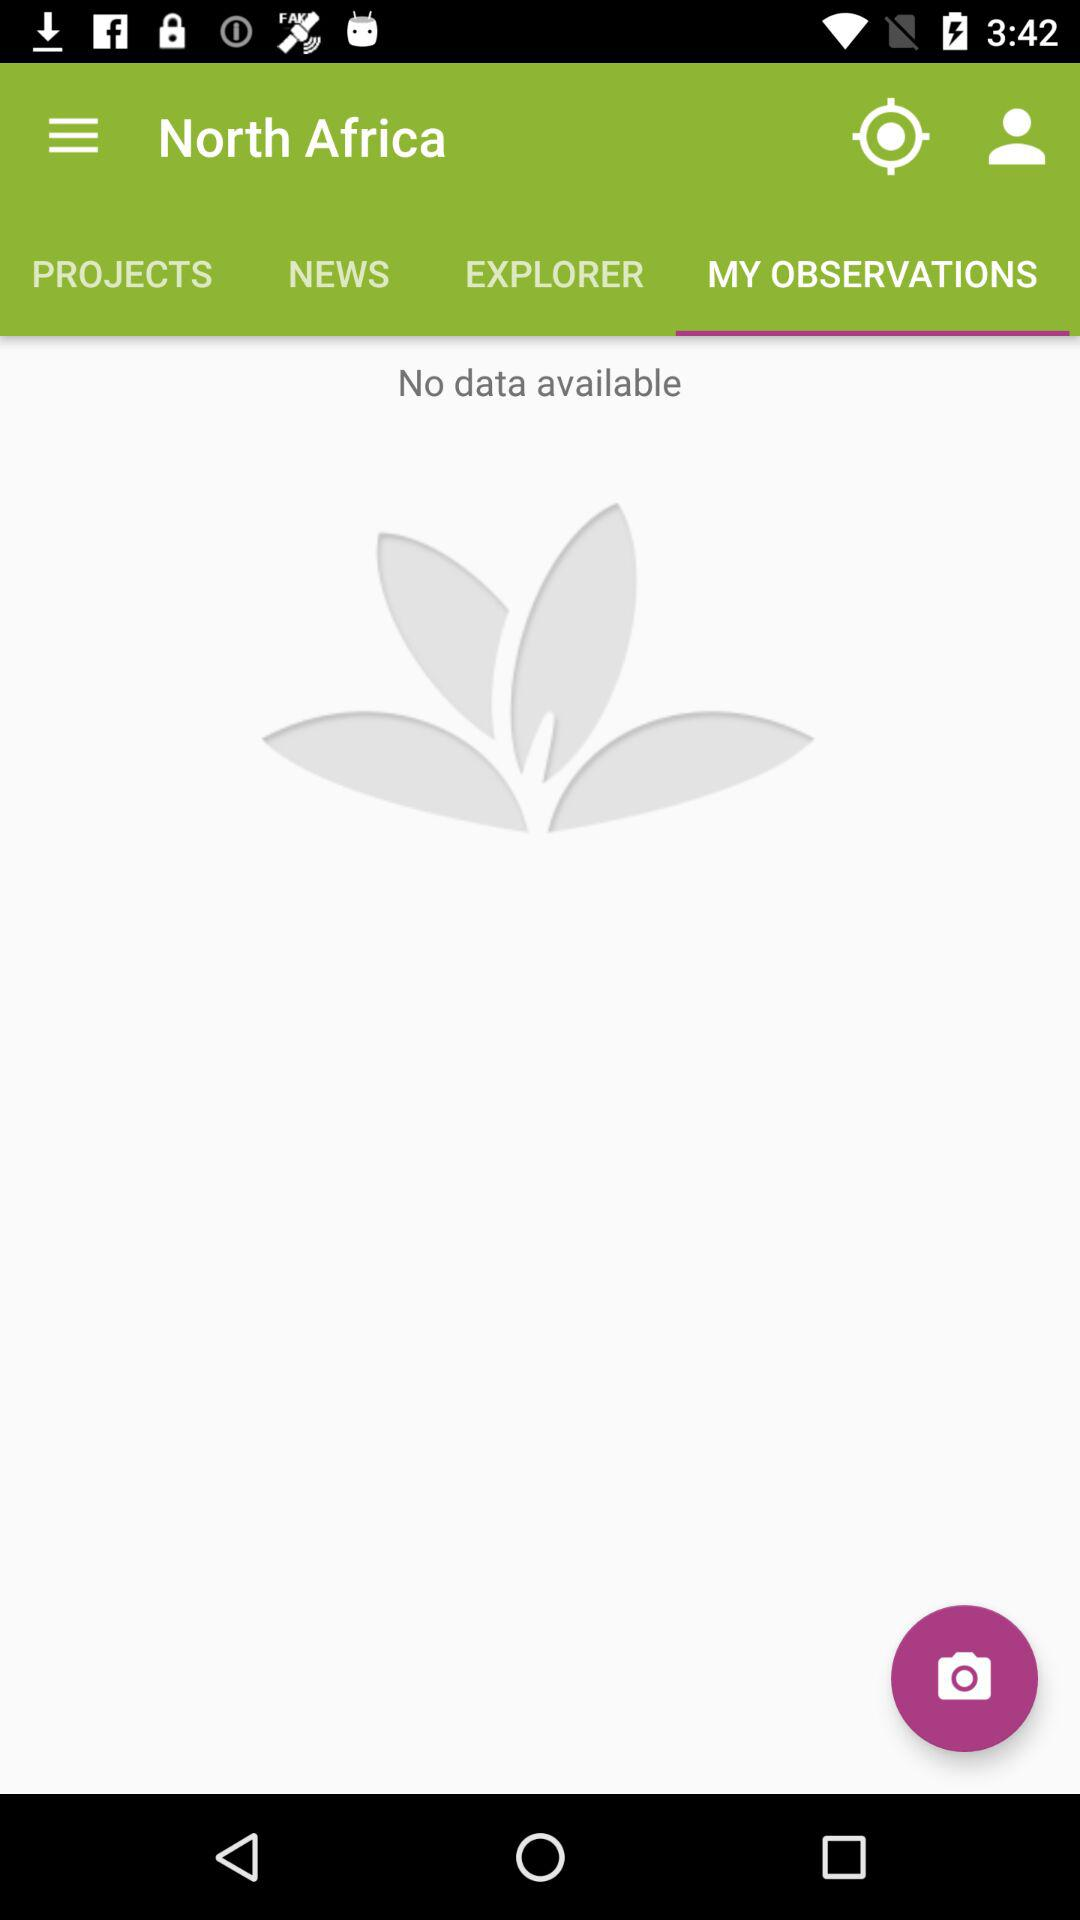Is there any data available? There is no data available. 